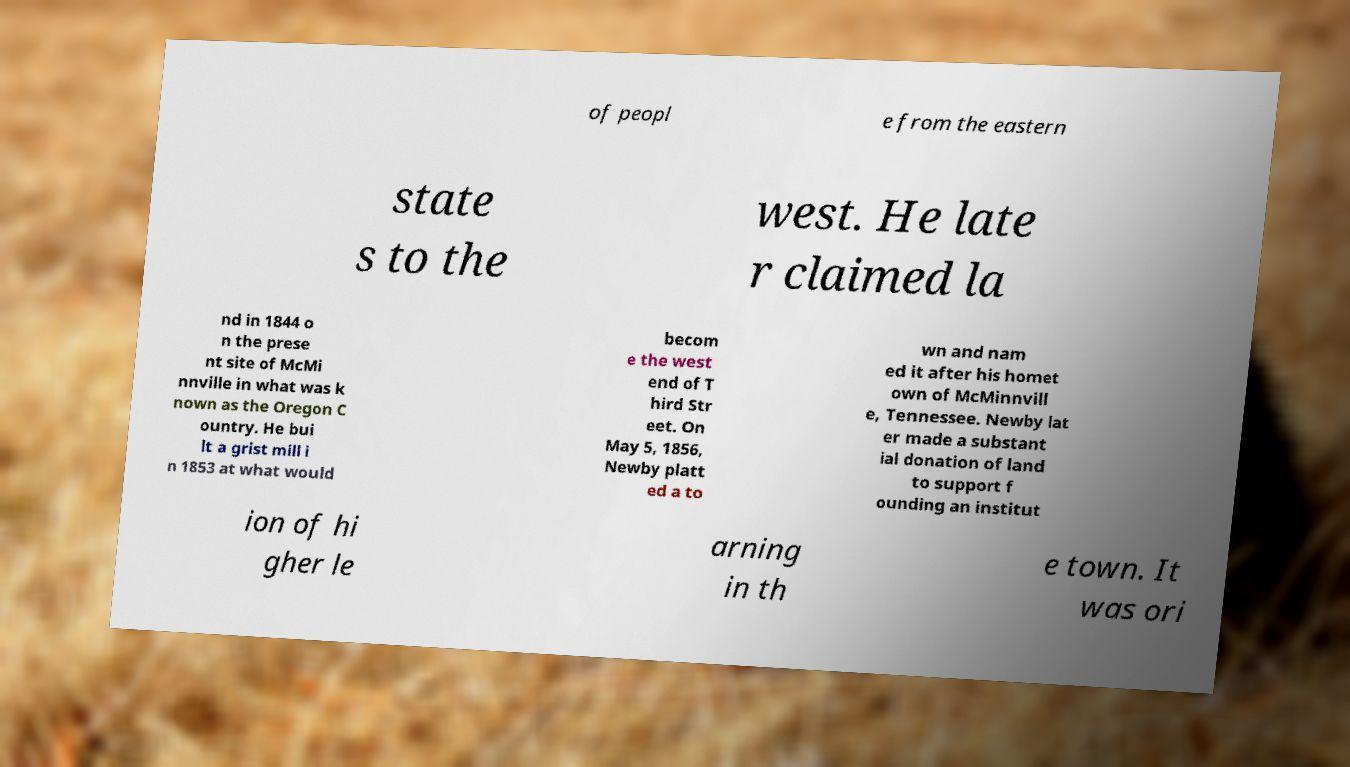Can you accurately transcribe the text from the provided image for me? of peopl e from the eastern state s to the west. He late r claimed la nd in 1844 o n the prese nt site of McMi nnville in what was k nown as the Oregon C ountry. He bui lt a grist mill i n 1853 at what would becom e the west end of T hird Str eet. On May 5, 1856, Newby platt ed a to wn and nam ed it after his homet own of McMinnvill e, Tennessee. Newby lat er made a substant ial donation of land to support f ounding an institut ion of hi gher le arning in th e town. It was ori 